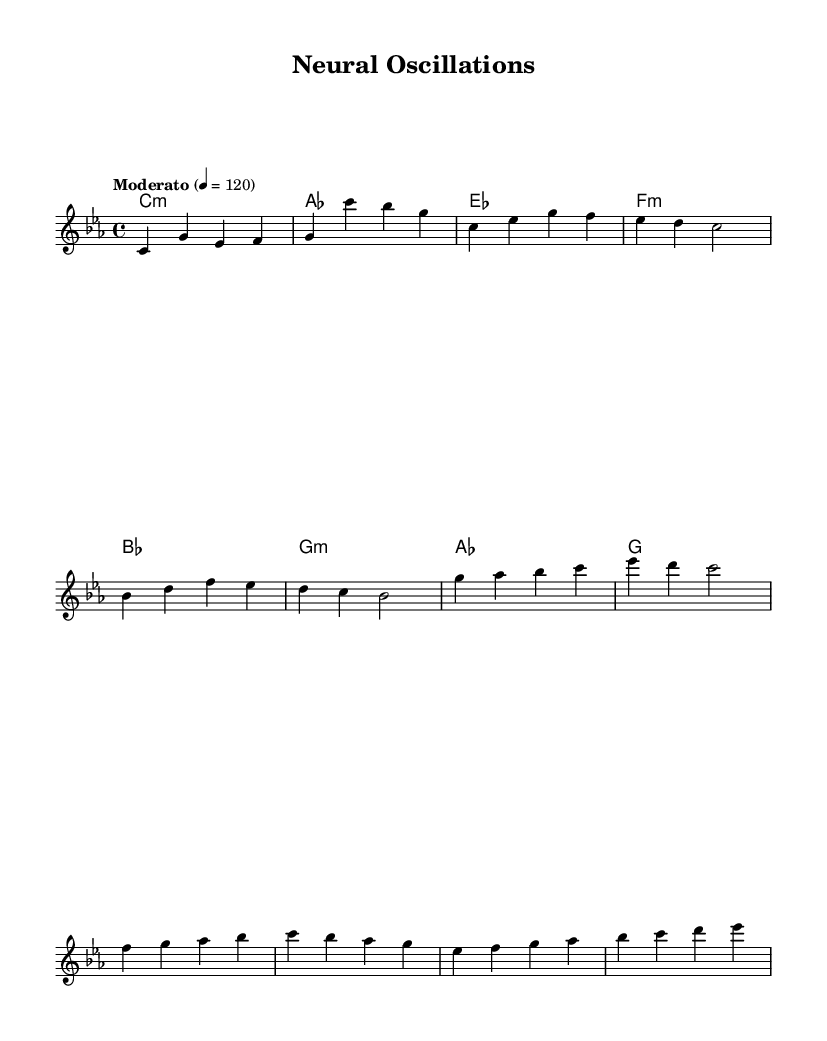What is the key signature of this music? The key signature is indicated at the beginning of the score, showing C minor, which has three flats (B♭, E♭, and A♭).
Answer: C minor What is the time signature of this piece? The time signature is 4/4, meaning there are four beats per measure, and the quarter note gets one beat. This is noted at the start of the sheet music.
Answer: 4/4 What is the tempo marking used in this score? The tempo marking is indicated as "Moderato" with a tempo of 120 beats per minute, shown at the beginning of the piece.
Answer: Moderato How many measures are there in the verse section? By counting the measures labeled under the verse section, we find there are four measures present in that section.
Answer: 4 What is the final note of the chorus? The final note of the chorus, as indicated in the melody part, is G, which appears at the end of the fourth measure of the chorus.
Answer: G Which chord is used after the first measure in the harmonies? After the first measure, the harmonies indicate the chord C minor is played, as shown in the chord mode.
Answer: C minor What are the three chords used in the bridge section? By examining the bridge section, we see the chords are E♭, F minor, and G, which are listed sequentially in the score.
Answer: E♭, F minor, G 